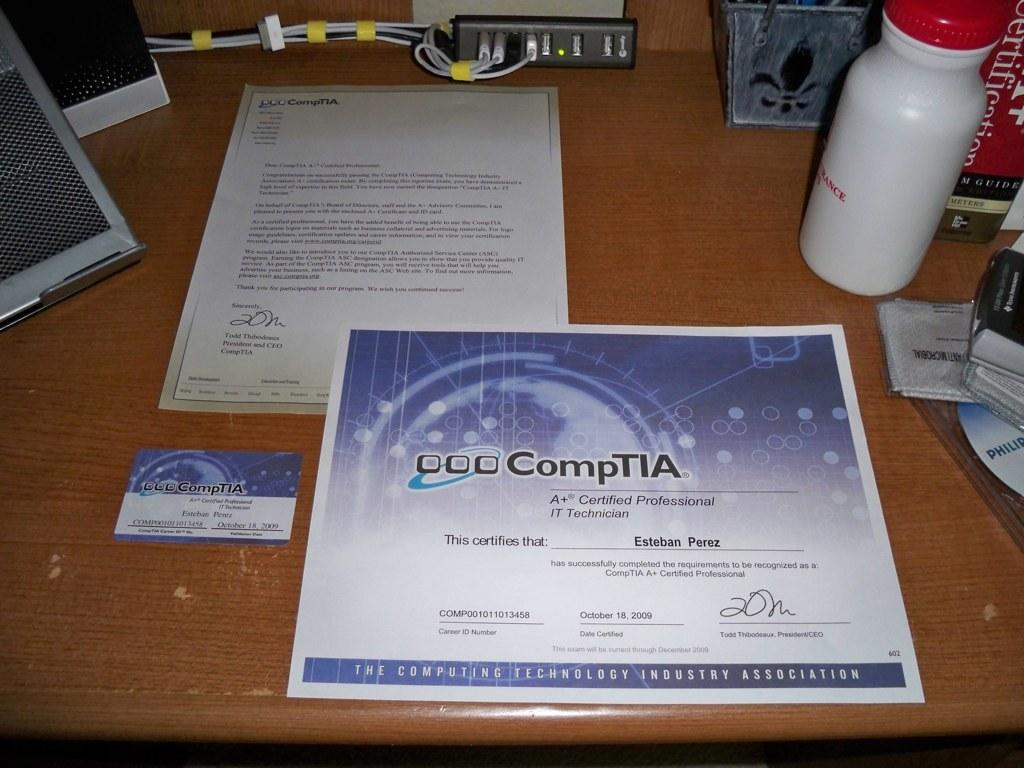<image>
Describe the image concisely. the word comptia is on the piece of paper 